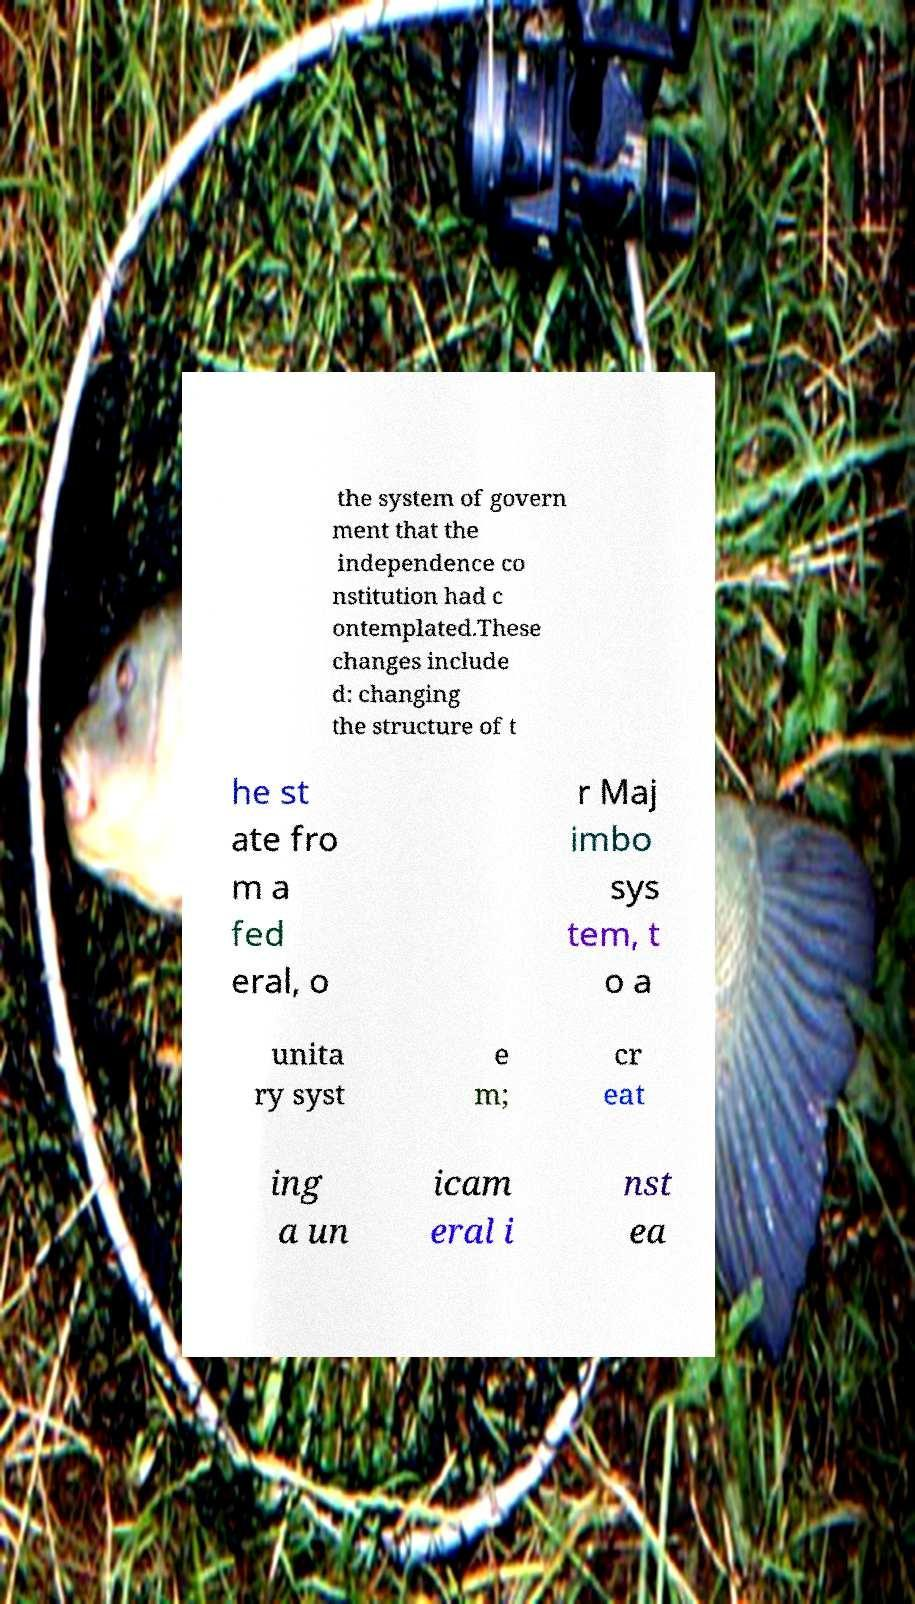Please read and relay the text visible in this image. What does it say? the system of govern ment that the independence co nstitution had c ontemplated.These changes include d: changing the structure of t he st ate fro m a fed eral, o r Maj imbo sys tem, t o a unita ry syst e m; cr eat ing a un icam eral i nst ea 